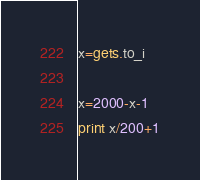<code> <loc_0><loc_0><loc_500><loc_500><_Ruby_>x=gets.to_i

x=2000-x-1
print x/200+1
</code> 